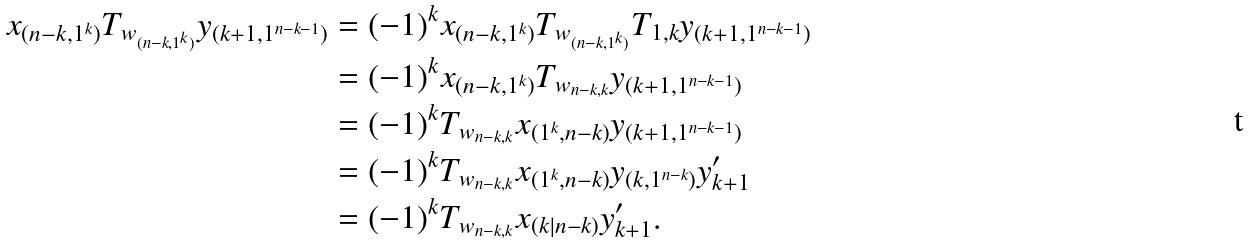<formula> <loc_0><loc_0><loc_500><loc_500>x _ { ( n - k , 1 ^ { k } ) } T _ { w _ { ( n - k , 1 ^ { k } ) } } y _ { ( k + 1 , 1 ^ { n - k - 1 } ) } & = ( - 1 ) ^ { k } x _ { ( n - k , 1 ^ { k } ) } T _ { w _ { ( n - k , 1 ^ { k } ) } } T _ { 1 , k } y _ { ( k + 1 , 1 ^ { n - k - 1 } ) } \\ & = ( - 1 ) ^ { k } x _ { ( n - k , 1 ^ { k } ) } T _ { w _ { n - k , k } } y _ { ( k + 1 , 1 ^ { n - k - 1 } ) } \\ & = ( - 1 ) ^ { k } T _ { w _ { n - k , k } } x _ { ( 1 ^ { k } , n - k ) } y _ { ( k + 1 , 1 ^ { n - k - 1 } ) } \\ & = ( - 1 ) ^ { k } T _ { w _ { n - k , k } } x _ { ( 1 ^ { k } , n - k ) } y _ { ( k , 1 ^ { n - k } ) } y _ { k + 1 } ^ { \prime } \\ & = ( - 1 ) ^ { k } T _ { w _ { n - k , k } } x _ { ( k | n { - } k ) } y _ { k + 1 } ^ { \prime } .</formula> 